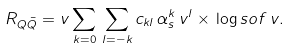Convert formula to latex. <formula><loc_0><loc_0><loc_500><loc_500>R _ { Q \bar { Q } } = v \sum _ { k = 0 } \, \sum _ { l = - k } c _ { k l } \, \alpha _ { s } ^ { k } \, v ^ { l } \times \, \log s o f \, v .</formula> 